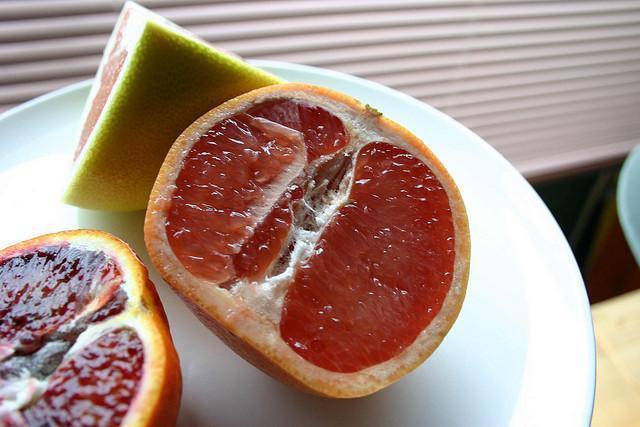How many oranges are there?
Give a very brief answer. 3. How many carrots are on top of the cartoon image?
Give a very brief answer. 0. 